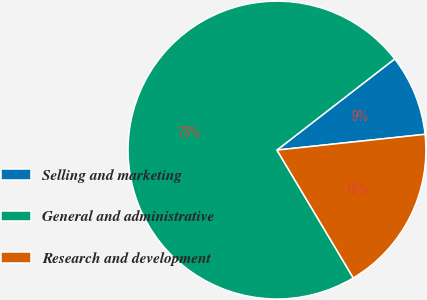<chart> <loc_0><loc_0><loc_500><loc_500><pie_chart><fcel>Selling and marketing<fcel>General and administrative<fcel>Research and development<nl><fcel>8.8%<fcel>73.08%<fcel>18.12%<nl></chart> 